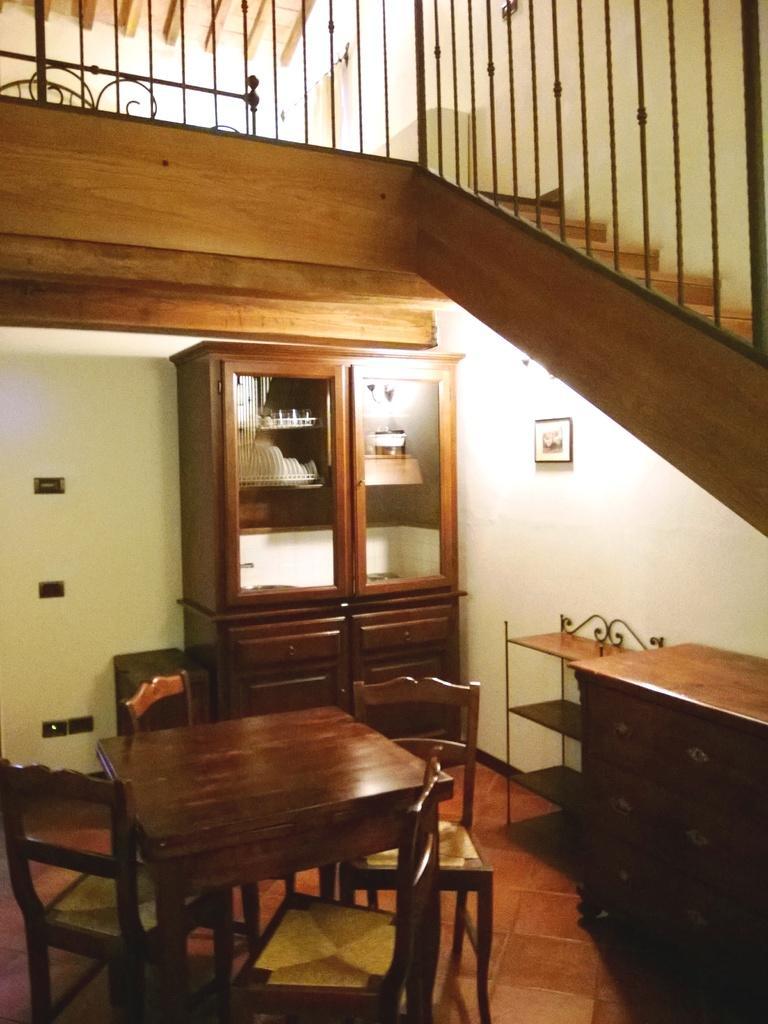Describe this image in one or two sentences. Here we can see a photo frame over a wall. we can see cupboard. We can see chairs and tables hire. these are stairs. This is a floor. 